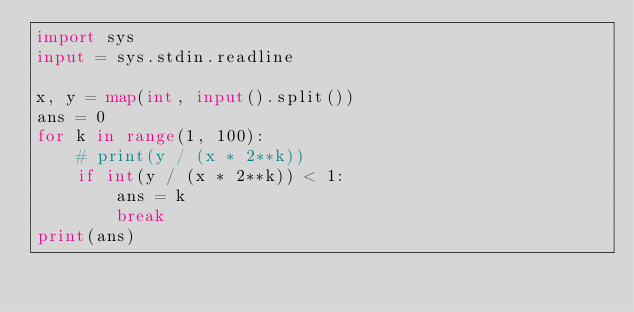Convert code to text. <code><loc_0><loc_0><loc_500><loc_500><_Python_>import sys
input = sys.stdin.readline

x, y = map(int, input().split())
ans = 0
for k in range(1, 100):
    # print(y / (x * 2**k))
    if int(y / (x * 2**k)) < 1:
        ans = k
        break
print(ans)</code> 